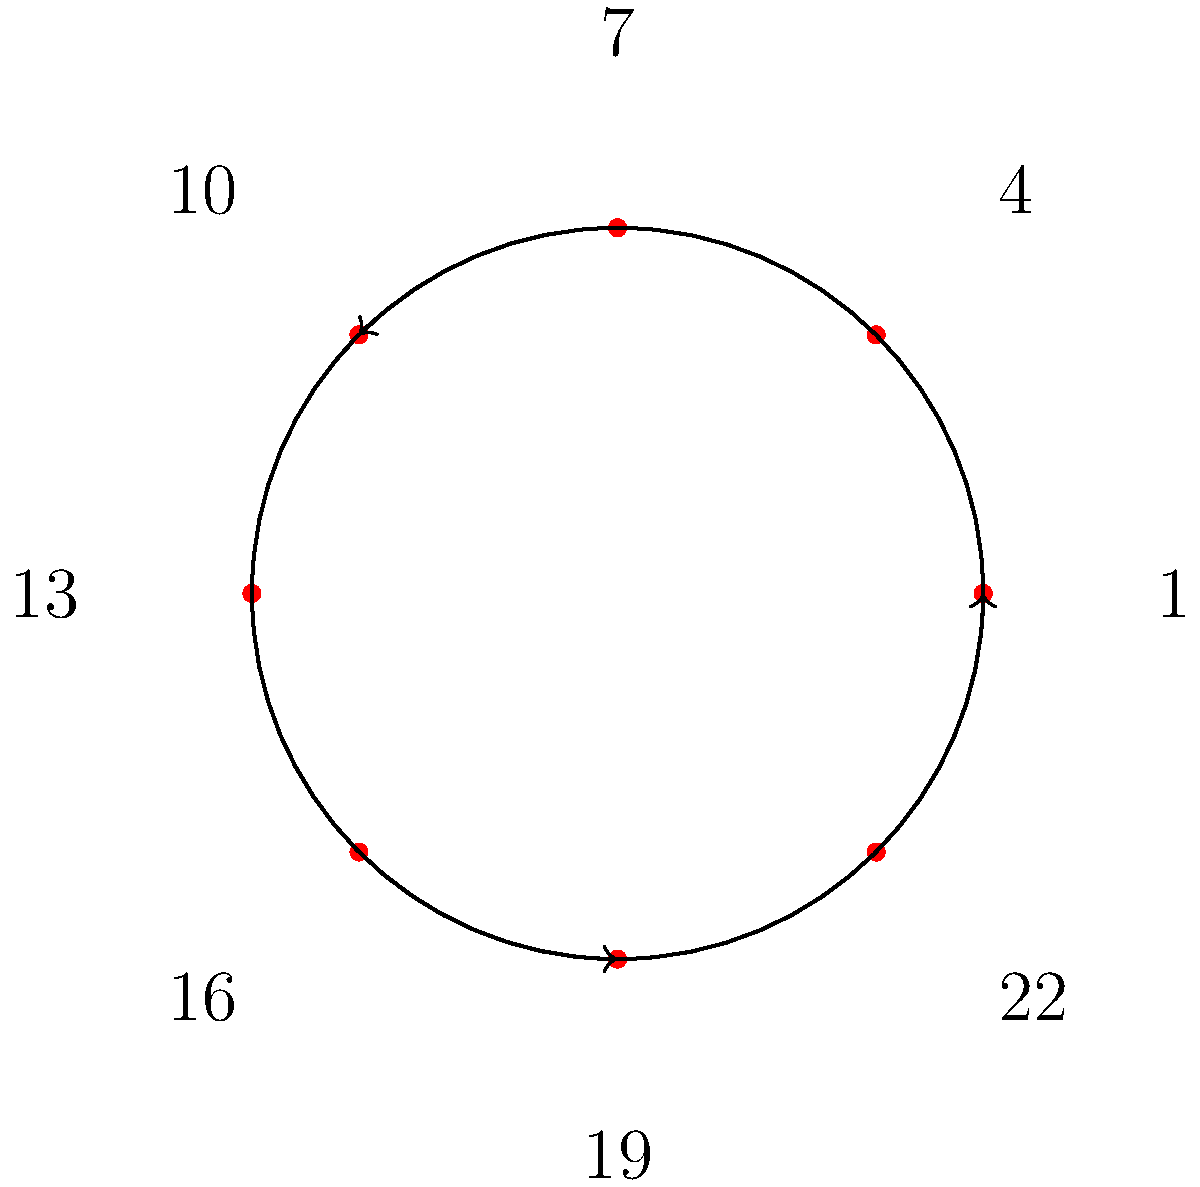Consider the jersey numbers of Pafos FC players: 1, 4, 7, 10, 13, 16, 19, and 22. If we define an operation on these numbers as addition modulo 23, what is the order of the cyclic subgroup generated by the number 4? To find the order of the cyclic subgroup generated by 4, we need to follow these steps:

1) First, let's understand what the operation means. Addition modulo 23 means we add numbers normally, but if the result is 23 or greater, we subtract 23 until we get a number less than 23.

2) Now, let's generate the subgroup starting with 4:
   $4^1 \equiv 4 \pmod{23}$
   $4^2 \equiv 4 + 4 \equiv 8 \pmod{23}$
   $4^3 \equiv 8 + 4 \equiv 12 \pmod{23}$
   $4^4 \equiv 12 + 4 \equiv 16 \pmod{23}$
   $4^5 \equiv 16 + 4 \equiv 20 \pmod{23}$
   $4^6 \equiv 20 + 4 \equiv 1 \pmod{23}$
   $4^7 \equiv 1 + 4 \equiv 5 \pmod{23}$
   $4^8 \equiv 5 + 4 \equiv 9 \pmod{23}$

3) We continue this process until we get back to 4. The full sequence is:
   4, 8, 12, 16, 20, 1, 5, 9, 13, 17, 21, 2, 6, 10, 14, 18, 22, 3, 7, 11, 15, 19, 0

4) We see that it takes 23 steps to get back to 4 (0 is equivalent to 23 in mod 23).

5) Therefore, the order of the cyclic subgroup generated by 4 is 23.

Note: This also shows that 4 is a generator of the entire group of integers modulo 23, as it generates all numbers from 0 to 22.
Answer: 23 